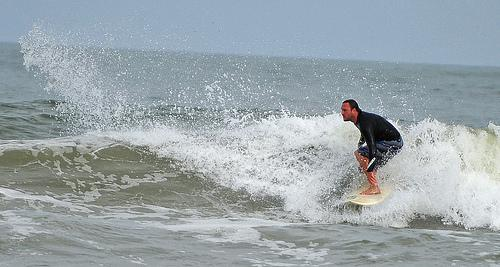Question: who is surfing?
Choices:
A. The man.
B. The woman.
C. The boy.
D. The girl.
Answer with the letter. Answer: A Question: what is the color of the top the man wearing?
Choices:
A. Blue.
B. Green.
C. Black.
D. Red.
Answer with the letter. Answer: C Question: where is the scene?
Choices:
A. In the forest.
B. On the beach.
C. On the boat.
D. In the sea.
Answer with the letter. Answer: D Question: what is the man doing?
Choices:
A. Skiing.
B. Driving.
C. Surfing.
D. Running.
Answer with the letter. Answer: C 